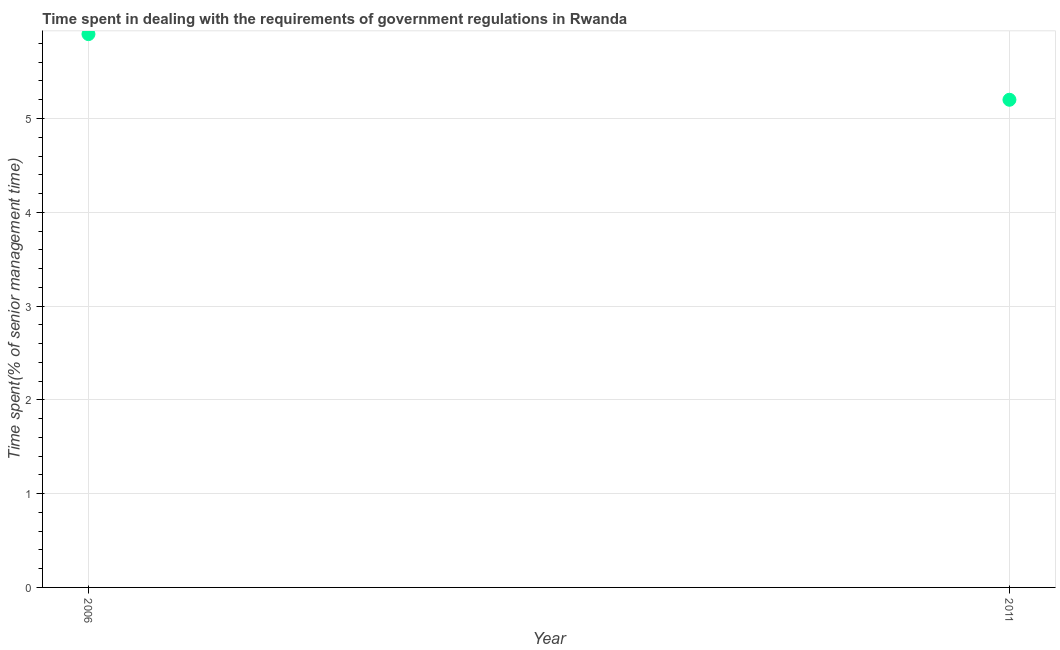Across all years, what is the minimum time spent in dealing with government regulations?
Make the answer very short. 5.2. In which year was the time spent in dealing with government regulations maximum?
Give a very brief answer. 2006. What is the sum of the time spent in dealing with government regulations?
Your answer should be very brief. 11.1. What is the difference between the time spent in dealing with government regulations in 2006 and 2011?
Make the answer very short. 0.7. What is the average time spent in dealing with government regulations per year?
Keep it short and to the point. 5.55. What is the median time spent in dealing with government regulations?
Your answer should be compact. 5.55. In how many years, is the time spent in dealing with government regulations greater than 1.2 %?
Your answer should be compact. 2. What is the ratio of the time spent in dealing with government regulations in 2006 to that in 2011?
Your answer should be very brief. 1.13. Is the time spent in dealing with government regulations in 2006 less than that in 2011?
Ensure brevity in your answer.  No. What is the difference between two consecutive major ticks on the Y-axis?
Give a very brief answer. 1. Does the graph contain any zero values?
Your answer should be very brief. No. Does the graph contain grids?
Provide a succinct answer. Yes. What is the title of the graph?
Provide a short and direct response. Time spent in dealing with the requirements of government regulations in Rwanda. What is the label or title of the Y-axis?
Make the answer very short. Time spent(% of senior management time). What is the Time spent(% of senior management time) in 2006?
Provide a succinct answer. 5.9. What is the Time spent(% of senior management time) in 2011?
Give a very brief answer. 5.2. What is the ratio of the Time spent(% of senior management time) in 2006 to that in 2011?
Your response must be concise. 1.14. 